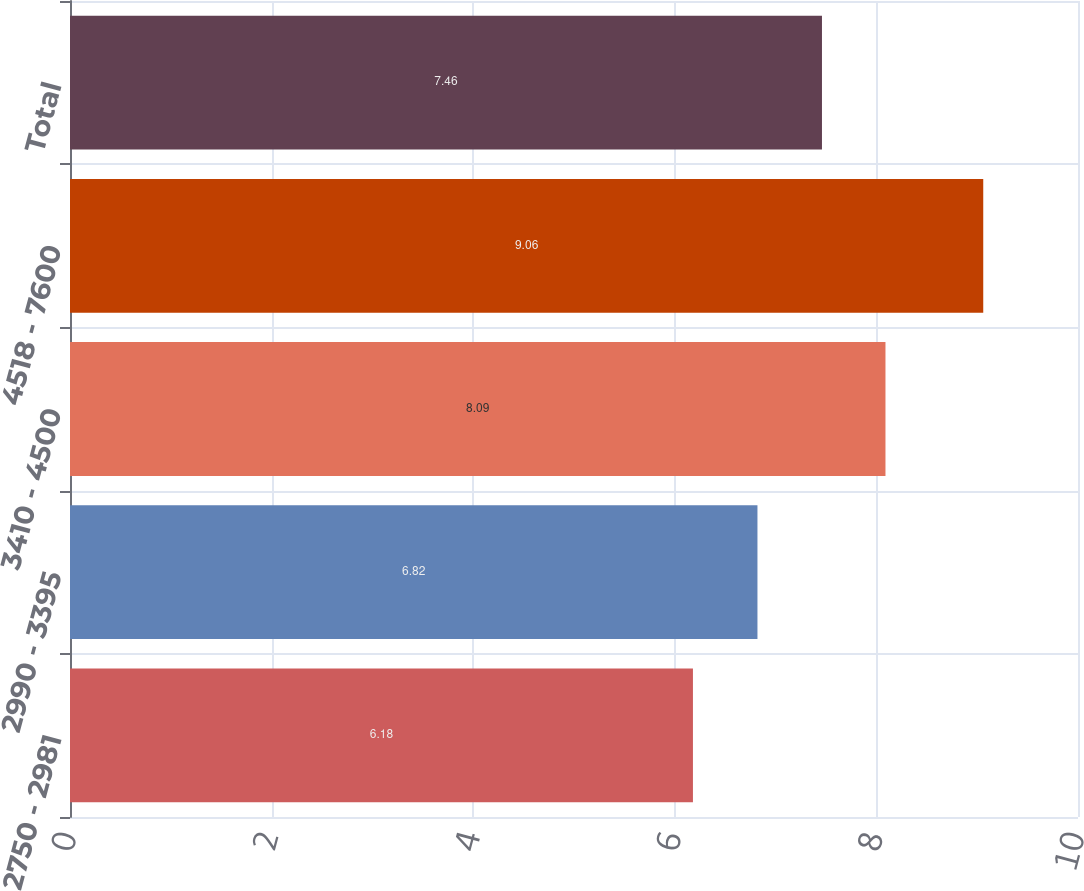<chart> <loc_0><loc_0><loc_500><loc_500><bar_chart><fcel>2750 - 2981<fcel>2990 - 3395<fcel>3410 - 4500<fcel>4518 - 7600<fcel>Total<nl><fcel>6.18<fcel>6.82<fcel>8.09<fcel>9.06<fcel>7.46<nl></chart> 